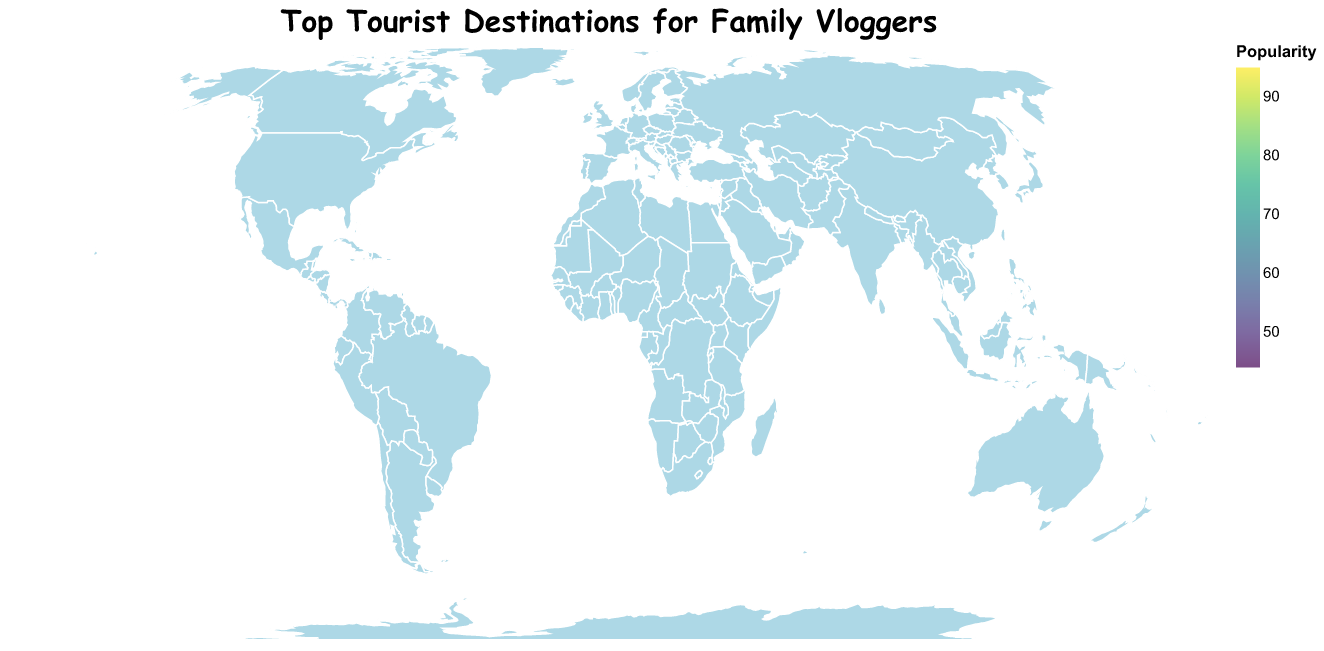What is the title of the map? The map title is displayed clearly at the top of the figure. The font and size make it stand out.
Answer: Top Tourist Destinations for Family Vloggers What color is used to represent the popularity? The visual uses the 'viridis' color scheme, ranging from blue for less popular to yellow for more popular destinations. The legend indicates this color gradient.
Answer: A gradient from blue to yellow How many tourist destinations are plotted on the map? By counting the circles on the map, we see there are 15 data points corresponding to the 15 listed destinations.
Answer: 15 Which tourist destination has the highest popularity? The size of the circle and the color intensity help indicate the popularity. Disneyland Paris has the largest circle and most vibrant color.
Answer: Disneyland Paris Which tourist destination is the least popular? The smallest and darkest circle represents the least popularity, which corresponds to the Colosseum.
Answer: Colosseum What are the coordinates (latitude and longitude) of the Great Barrier Reef? By identifying the Great Barrier Reef on the map and referencing its location in the dataset, we can find its coordinates.
Answer: -18.2871, 147.6992 How do the popularity levels of Disneyland Paris and Tokyo Disneyland compare? Disneyland Paris has a popularity of 95, while Tokyo Disneyland has 65. Disneyland Paris is significantly more popular.
Answer: Disneyland Paris is more popular Which continents feature tourist destinations in the top 15? Count the number of destinations per continent. By identifying the geographic locations of the destinations on each continent: Europe (4 - Disneyland Paris, Eiffel Tower, Santorini, Colosseum), North America (2 - Yellowstone National Park, Niagara Falls), Asia (4 - Universal Studios Japan, Great Wall of China, Tokyo Disneyland, Bali), South America (1 - Machu Picchu), Africa (1 - Kruger National Park), Australia (1 - Great Barrier Reef).
Answer: Europe, North America, Asia, South America, Africa, Australia What is the difference in popularity between Yellowstone National Park and Banff National Park? Yellowstone's popularity is 79, and Banff's is 72. Subtract 72 from 79 to find the difference.
Answer: 7 Which destination has a higher latitude, Banff National Park or Niagara Falls? By comparing their latitudes: Banff (51.4968) and Niagara Falls (43.0962), Banff is further north.
Answer: Banff National Park 